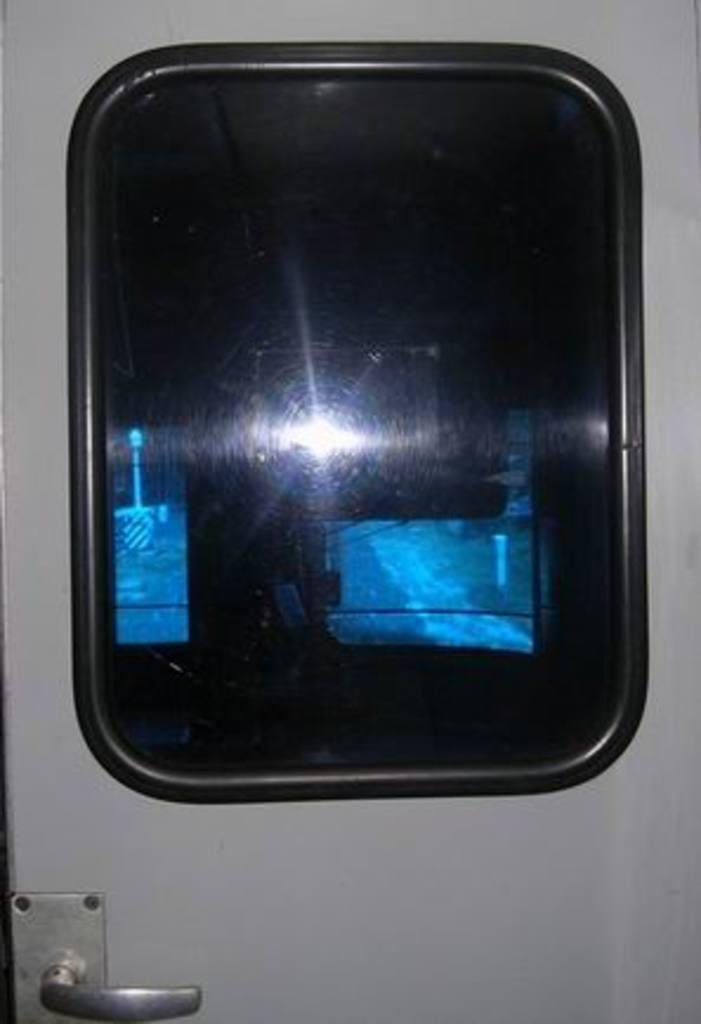What is the main object in the image? There is a door in the image. What feature does the door have? The door has a handle. What degree does the door have in the image? The image does not provide information about the degree of the door. The question is not relevant to the image. 